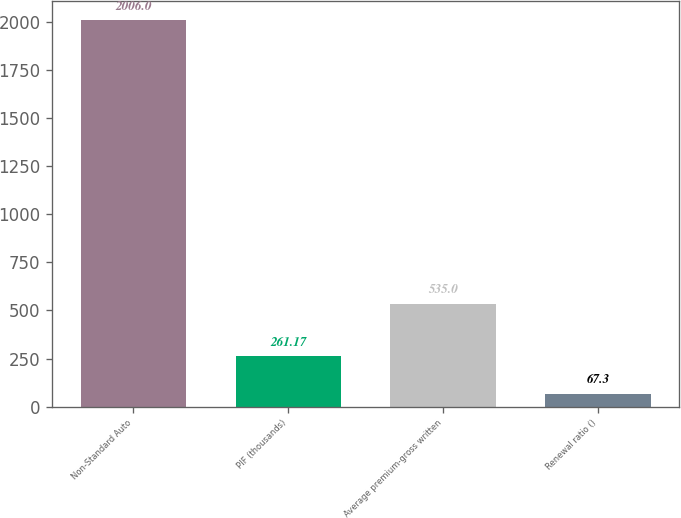Convert chart. <chart><loc_0><loc_0><loc_500><loc_500><bar_chart><fcel>Non-Standard Auto<fcel>PIF (thousands)<fcel>Average premium-gross written<fcel>Renewal ratio ()<nl><fcel>2006<fcel>261.17<fcel>535<fcel>67.3<nl></chart> 